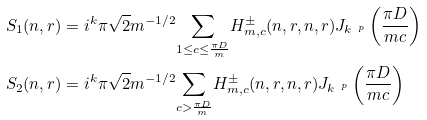<formula> <loc_0><loc_0><loc_500><loc_500>& S _ { 1 } ( n , r ) = i ^ { k } \pi \sqrt { 2 } m ^ { - 1 / 2 } \underset { 1 \leq c \leq \frac { \pi D } { m } } \sum H _ { m , c } ^ { \pm } ( n , r , n , r ) J _ { k ^ { \ p } } \left ( \frac { \pi D } { m c } \right ) \\ & S _ { 2 } ( n , r ) = i ^ { k } \pi \sqrt { 2 } m ^ { - 1 / 2 } \underset { c > \frac { \pi D } { m } } \sum H _ { m , c } ^ { \pm } ( n , r , n , r ) J _ { k ^ { \ p } } \left ( \frac { \pi D } { m c } \right )</formula> 